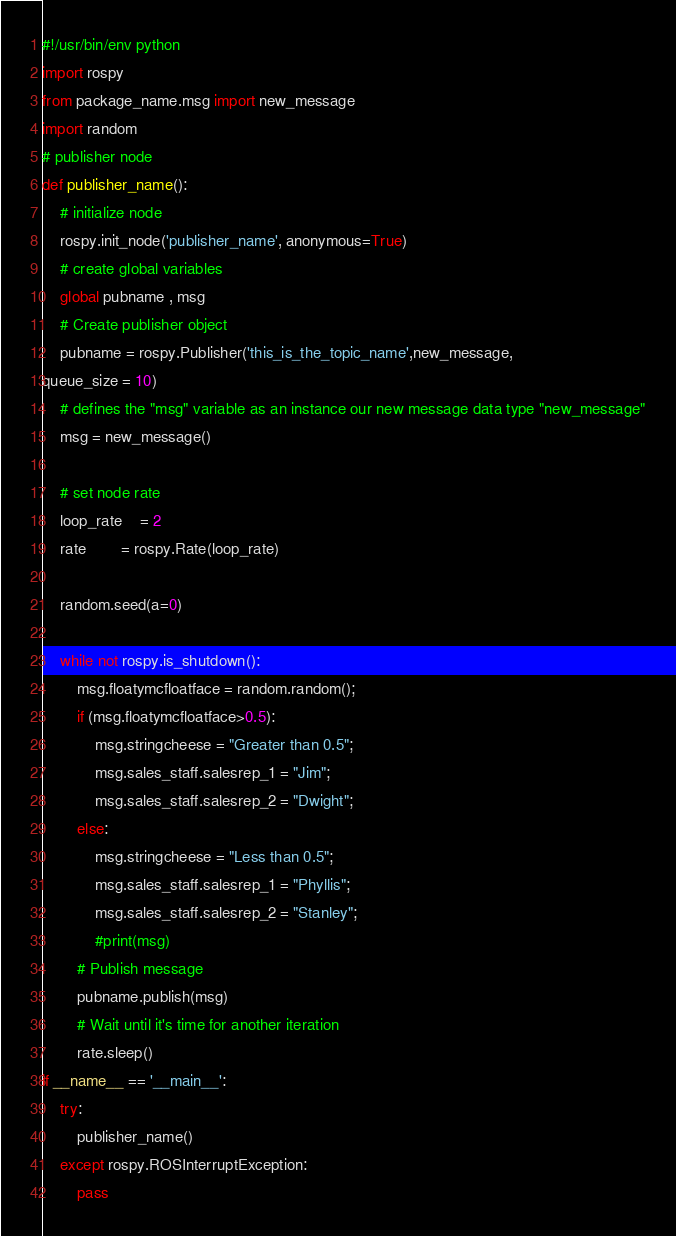<code> <loc_0><loc_0><loc_500><loc_500><_Python_>#!/usr/bin/env python
import rospy
from package_name.msg import new_message
import random
# publisher node
def publisher_name():
	# initialize node
	rospy.init_node('publisher_name', anonymous=True)
	# create global variables
	global pubname , msg
	# Create publisher object
	pubname = rospy.Publisher('this_is_the_topic_name',new_message,
queue_size = 10)
	# defines the "msg" variable as an instance our new message data type "new_message"
	msg = new_message()

	# set node rate
	loop_rate 	= 2
	rate 		= rospy.Rate(loop_rate)

	random.seed(a=0)
	
	while not rospy.is_shutdown():
		msg.floatymcfloatface = random.random();
		if (msg.floatymcfloatface>0.5):
			msg.stringcheese = "Greater than 0.5";
			msg.sales_staff.salesrep_1 = "Jim";
			msg.sales_staff.salesrep_2 = "Dwight";
		else:
			msg.stringcheese = "Less than 0.5";
			msg.sales_staff.salesrep_1 = "Phyllis";
			msg.sales_staff.salesrep_2 = "Stanley";
			#print(msg)
		# Publish message
		pubname.publish(msg)
		# Wait until it's time for another iteration
		rate.sleep()
if __name__ == '__main__':
	try:
		publisher_name()
	except rospy.ROSInterruptException:
		pass</code> 